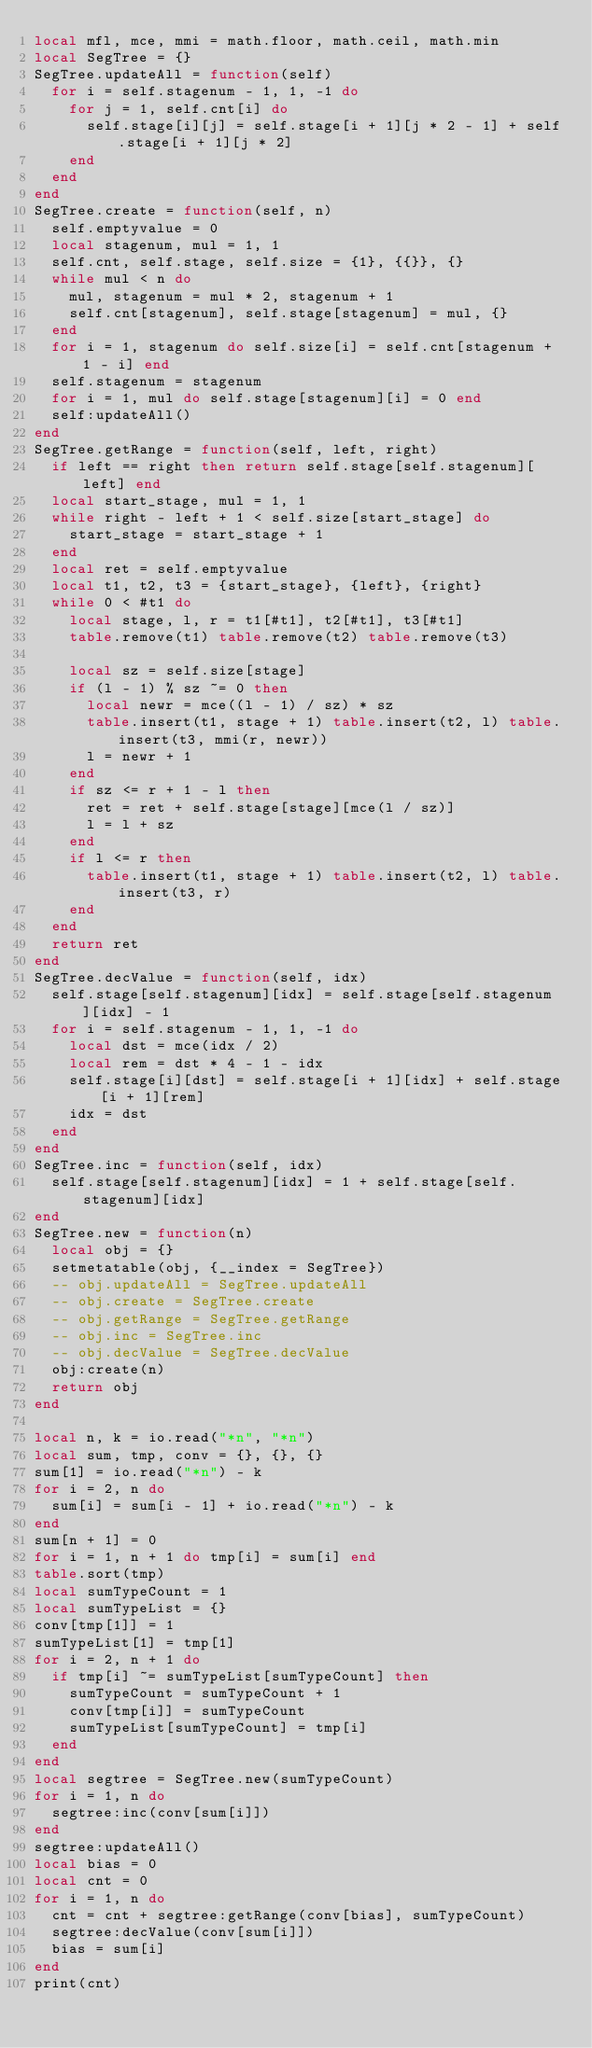<code> <loc_0><loc_0><loc_500><loc_500><_Lua_>local mfl, mce, mmi = math.floor, math.ceil, math.min
local SegTree = {}
SegTree.updateAll = function(self)
  for i = self.stagenum - 1, 1, -1 do
    for j = 1, self.cnt[i] do
      self.stage[i][j] = self.stage[i + 1][j * 2 - 1] + self.stage[i + 1][j * 2]
    end
  end
end
SegTree.create = function(self, n)
  self.emptyvalue = 0
  local stagenum, mul = 1, 1
  self.cnt, self.stage, self.size = {1}, {{}}, {}
  while mul < n do
    mul, stagenum = mul * 2, stagenum + 1
    self.cnt[stagenum], self.stage[stagenum] = mul, {}
  end
  for i = 1, stagenum do self.size[i] = self.cnt[stagenum + 1 - i] end
  self.stagenum = stagenum
  for i = 1, mul do self.stage[stagenum][i] = 0 end
  self:updateAll()
end
SegTree.getRange = function(self, left, right)
  if left == right then return self.stage[self.stagenum][left] end
  local start_stage, mul = 1, 1
  while right - left + 1 < self.size[start_stage] do
    start_stage = start_stage + 1
  end
  local ret = self.emptyvalue
  local t1, t2, t3 = {start_stage}, {left}, {right}
  while 0 < #t1 do
    local stage, l, r = t1[#t1], t2[#t1], t3[#t1]
    table.remove(t1) table.remove(t2) table.remove(t3)

    local sz = self.size[stage]
    if (l - 1) % sz ~= 0 then
      local newr = mce((l - 1) / sz) * sz
      table.insert(t1, stage + 1) table.insert(t2, l) table.insert(t3, mmi(r, newr))
      l = newr + 1
    end
    if sz <= r + 1 - l then
      ret = ret + self.stage[stage][mce(l / sz)]
      l = l + sz
    end
    if l <= r then
      table.insert(t1, stage + 1) table.insert(t2, l) table.insert(t3, r)
    end
  end
  return ret
end
SegTree.decValue = function(self, idx)
  self.stage[self.stagenum][idx] = self.stage[self.stagenum][idx] - 1
  for i = self.stagenum - 1, 1, -1 do
    local dst = mce(idx / 2)
    local rem = dst * 4 - 1 - idx
    self.stage[i][dst] = self.stage[i + 1][idx] + self.stage[i + 1][rem]
    idx = dst
  end
end
SegTree.inc = function(self, idx)
  self.stage[self.stagenum][idx] = 1 + self.stage[self.stagenum][idx]
end
SegTree.new = function(n)
  local obj = {}
  setmetatable(obj, {__index = SegTree})
  -- obj.updateAll = SegTree.updateAll
  -- obj.create = SegTree.create
  -- obj.getRange = SegTree.getRange
  -- obj.inc = SegTree.inc
  -- obj.decValue = SegTree.decValue
  obj:create(n)
  return obj
end

local n, k = io.read("*n", "*n")
local sum, tmp, conv = {}, {}, {}
sum[1] = io.read("*n") - k
for i = 2, n do
  sum[i] = sum[i - 1] + io.read("*n") - k
end
sum[n + 1] = 0
for i = 1, n + 1 do tmp[i] = sum[i] end
table.sort(tmp)
local sumTypeCount = 1
local sumTypeList = {}
conv[tmp[1]] = 1
sumTypeList[1] = tmp[1]
for i = 2, n + 1 do
  if tmp[i] ~= sumTypeList[sumTypeCount] then
    sumTypeCount = sumTypeCount + 1
    conv[tmp[i]] = sumTypeCount
    sumTypeList[sumTypeCount] = tmp[i]
  end
end
local segtree = SegTree.new(sumTypeCount)
for i = 1, n do
  segtree:inc(conv[sum[i]])
end
segtree:updateAll()
local bias = 0
local cnt = 0
for i = 1, n do
  cnt = cnt + segtree:getRange(conv[bias], sumTypeCount)
  segtree:decValue(conv[sum[i]])
  bias = sum[i]
end
print(cnt)
</code> 